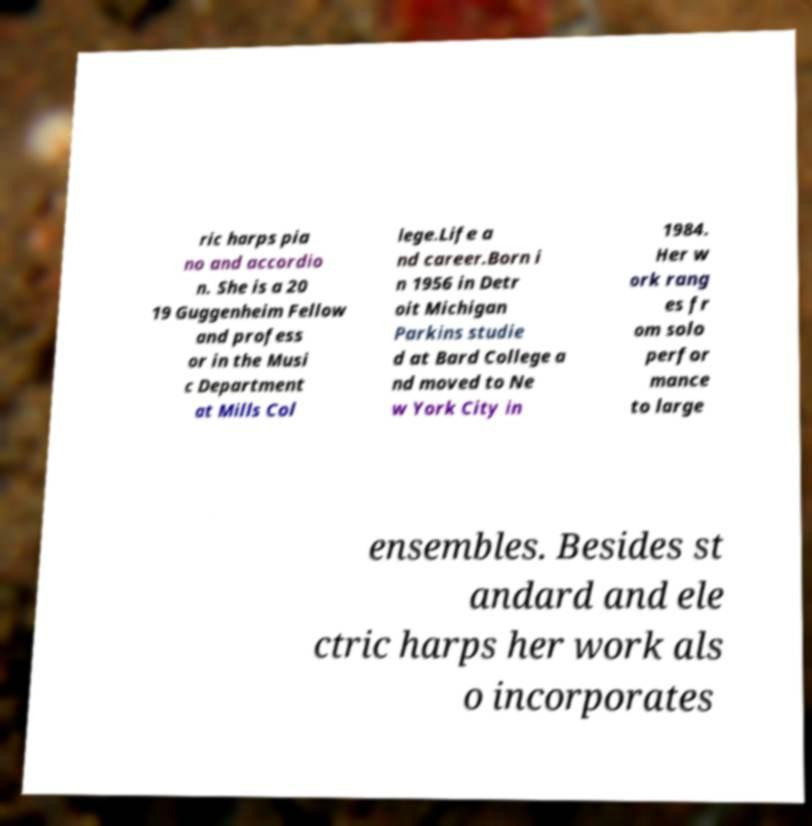Could you extract and type out the text from this image? ric harps pia no and accordio n. She is a 20 19 Guggenheim Fellow and profess or in the Musi c Department at Mills Col lege.Life a nd career.Born i n 1956 in Detr oit Michigan Parkins studie d at Bard College a nd moved to Ne w York City in 1984. Her w ork rang es fr om solo perfor mance to large ensembles. Besides st andard and ele ctric harps her work als o incorporates 